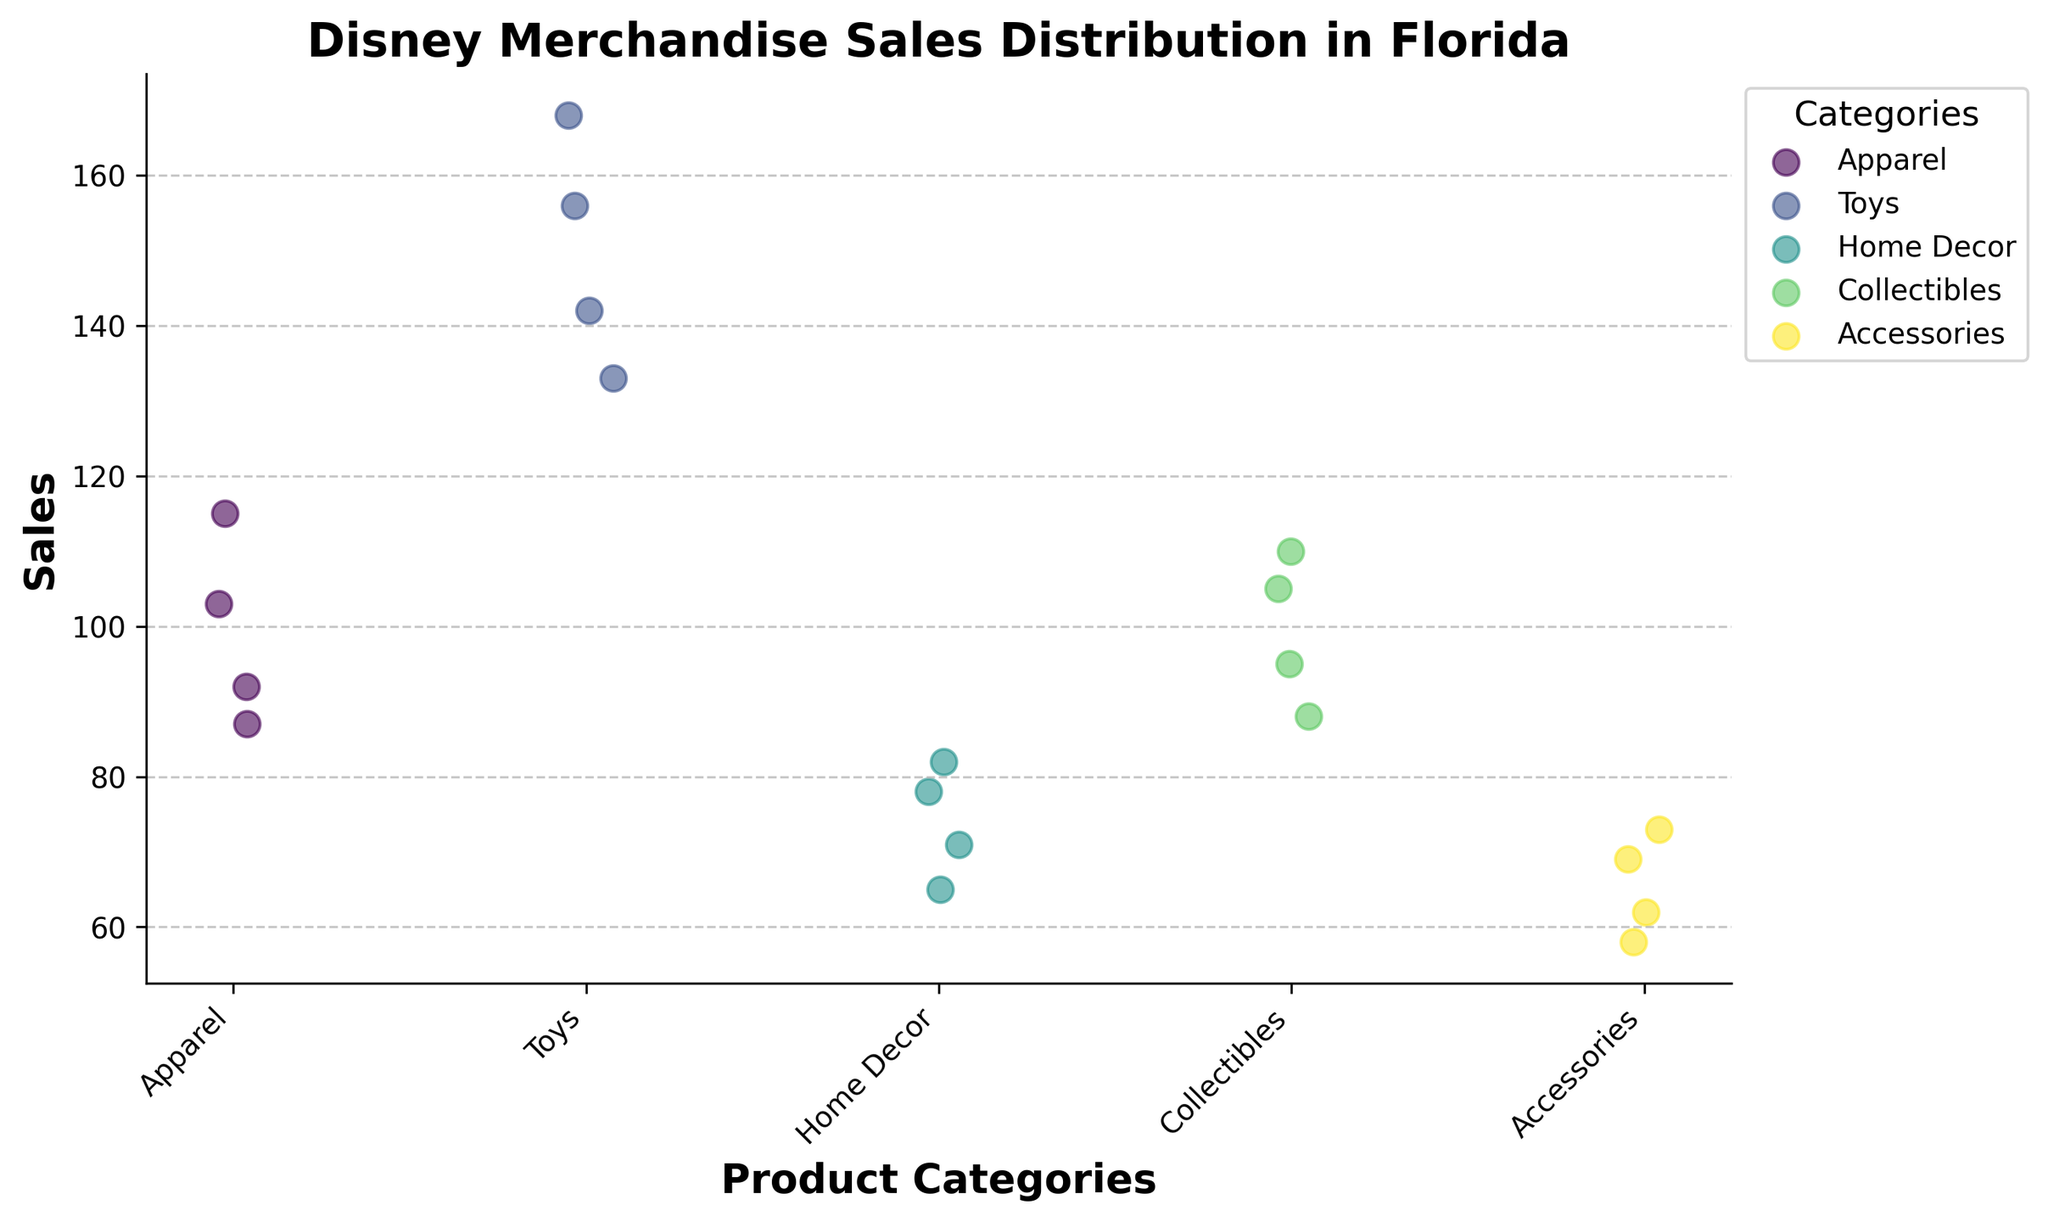What is the title of the figure? The title appears at the top of the figure and is usually in a larger and bolder font to distinguish it from other text.
Answer: Disney Merchandise Sales Distribution in Florida What is the median sales value for the Apparel category? To find the median, first, list the sales values for the Apparel category (87, 103, 92, 115) in ascending order: 87, 92, 103, 115. The median is the average of the two middle numbers: (92 + 103) / 2 = 97.5.
Answer: 97.5 Which product category has the highest average sales? Calculate the average sales for each category by summing the sales values and dividing by the number of data points. Accessories: (62 + 73 + 58 + 69) / 4 = 65.5, Apparel: (87 + 103 + 92 + 115) / 4 = 99.25, Collectibles: (95 + 110 + 88 + 105) / 4 = 99.5, Home Decor: (78 + 65 + 82 + 71) / 4 = 74, Toys: (156 + 142 + 168 + 133) / 4 = 149.75. Toys have the highest average sales.
Answer: Toys What is the range of sales values for the Home Decor category? The range is calculated by subtracting the minimum value from the maximum value. For Home Decor: maximum (82) - minimum (65) = 17.
Answer: 17 How many product categories are displayed in the figure? Count the unique product categories listed on the x-axis. They are Apparel, Toys, Home Decor, Collectibles, and Accessories, for a total of 5 categories.
Answer: 5 Which product category has the most variation in sales values? The variation can be approximate by observing the spread of sales values for each category. Collectibles and Toys seem to have a wider spread compared to others. Calculating the range can confirm: Collectibles range: 110 - 88 = 22, Toys range: 168 - 133 = 35, Apparel range: 115 - 87 = 28, Home Decor range: 82 - 65 = 17, Accessories range: 73 - 58 = 15. Toys have the most variation.
Answer: Toys What is the average sales value for Accessories? Add the sales values for Accessories and divide by the number of data points: (62 + 73 + 58 + 69) / 4 equals 65.5.
Answer: 65.5 Which product category has the highest single sale value? Observe the y-axis to identify the highest single sale value. Toys have a data point at 168, which is the highest value among all categories.
Answer: Toys What is the lowest sales value for Collectibles? Check the y-axis for the lowest point under the Collectibles category. The lowest sales value is 88 for Collectibles.
Answer: 88 Which product category has the most densely packed sales values? This can be observed by looking at how clustered the data points are. Accessories have closely packed data points ranging from 58 to 73, indicating they are most densely packed.
Answer: Accessories 